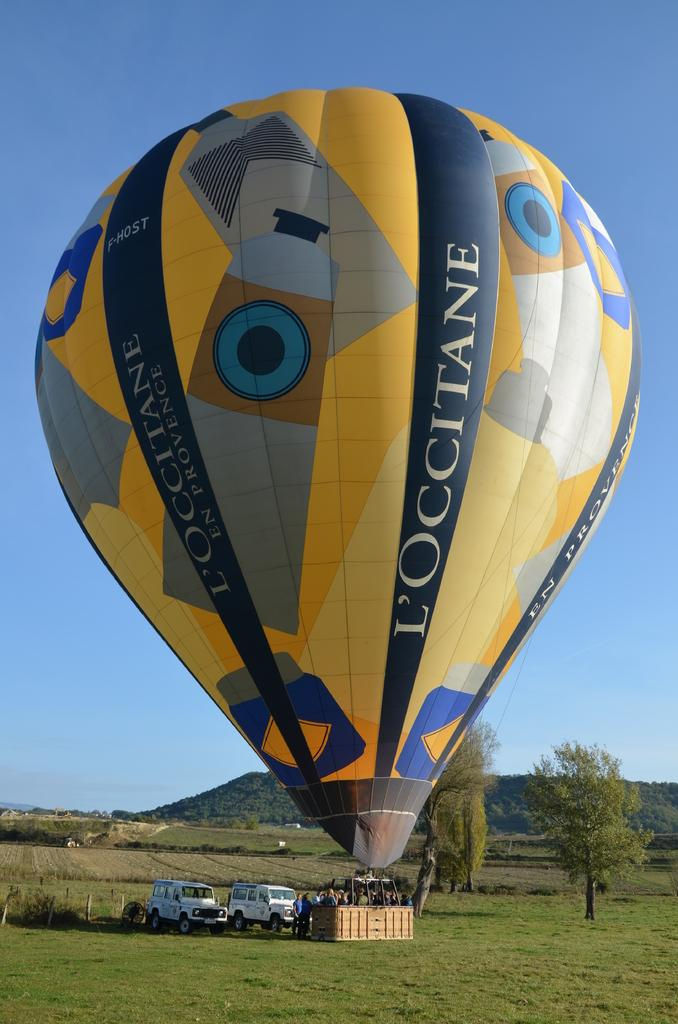What is the main subject of the image? The main subject of the image is an air-balloon. Are there any people present in the image? Yes, there are people near the air-balloon. What else can be seen in the image besides the air-balloon and people? There are vehicles visible in the image. What can be seen in the background of the image? In the background of the image, there are trees, mountains, and the sky. What type of manager is overseeing the writer in the image? There is no manager or writer present in the image; it features an air-balloon and people near it. 